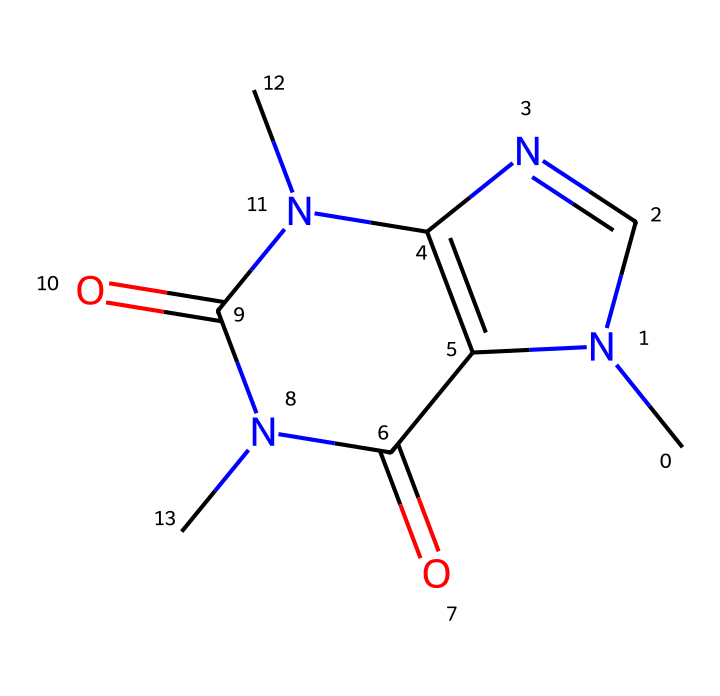What is the molecular formula of caffeine? Count the atoms represented in the SMILES: There are 8 carbon (C), 10 hydrogen (H), 4 nitrogen (N), and 2 oxygen (O) atoms. The molecular formula is thus constructed from these counts.
Answer: C8H10N4O2 How many nitrogen atoms are in the caffeine structure? The SMILES includes four occurrences of 'N', indicating the presence of four nitrogen atoms in the caffeine structure.
Answer: 4 What type of functional groups are present in caffeine? Analyzing the structure, caffeine contains amine (due to nitrogen atoms) and carbonyl (due to the double-bonded oxygen). Both functional groups can be confirmed by identifying the relevant bonds and atoms.
Answer: amine and carbonyl Is caffeine a heterocyclic compound? The structure contains a ring of carbon and nitrogen atoms, which confirms it has a cyclic structure that includes at least one element that is not carbon (nitrogen), hence it is a heterocyclic compound.
Answer: yes What is the role of caffeine in energy drinks? Caffeine acts as a stimulant, enhancing mental alertness and energy levels, which is why it is commonly included in energy drinks. It works by blocking adenosine receptors in the brain.
Answer: stimulant How many rings are present in the caffeine structure? By examining the structure, there are two interconnected rings comprised of carbon and nitrogen atoms. This is based on the cyclic nature indicated in the SMILES representation.
Answer: 2 